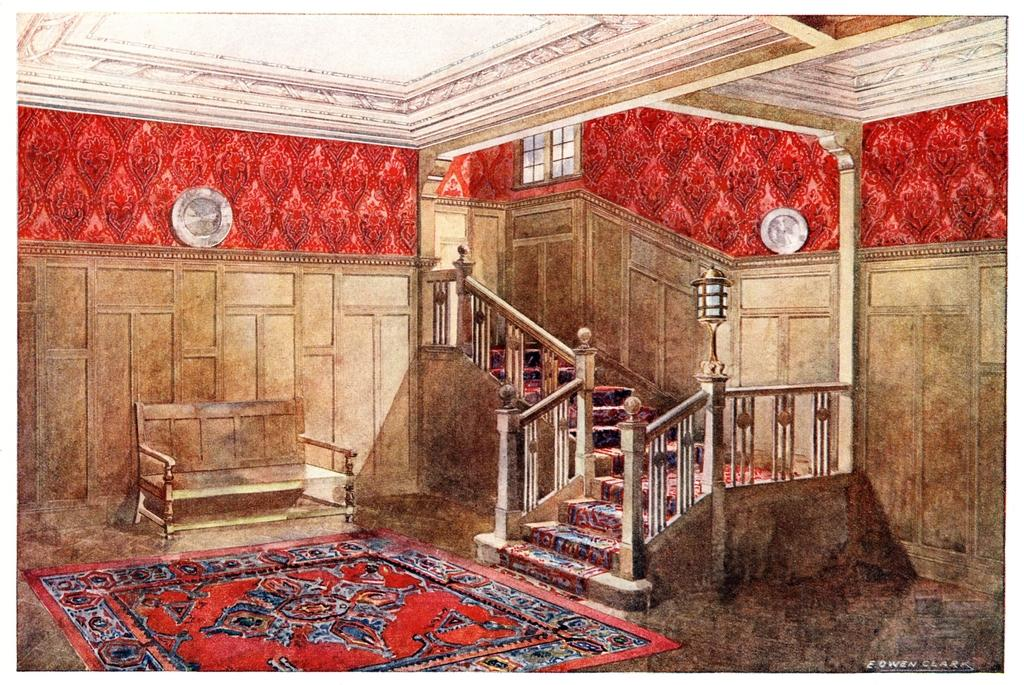What type of flooring is present in the image? There is a red color carpet on the floor. What type of furniture is in the image? There is a wooden bench in the image. What architectural feature is present in the image? There is a staircase in the image. What type of lighting is present in the image? There are lamps in the image. What type of wall is visible in the background? There is a wooden wall in the background. What type of ventilation system is present in the background? There are ventilators in the background. Can you tell me how many hens are sitting on the wooden bench in the image? There are no hens present in the image; it features a red carpet, wooden bench, staircase, lamps, wooden wall, and ventilators. What type of party is being held in the image? There is no party depicted in the image. 